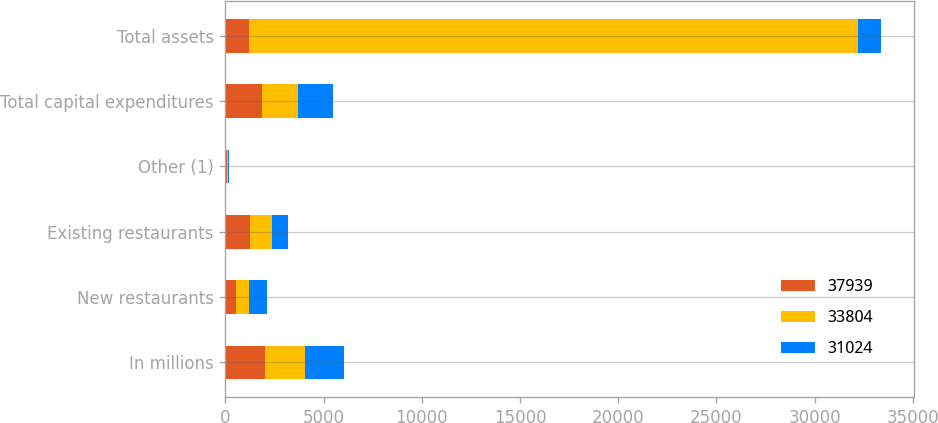<chart> <loc_0><loc_0><loc_500><loc_500><stacked_bar_chart><ecel><fcel>In millions<fcel>New restaurants<fcel>Existing restaurants<fcel>Other (1)<fcel>Total capital expenditures<fcel>Total assets<nl><fcel>37939<fcel>2017<fcel>537<fcel>1236<fcel>81<fcel>1854<fcel>1172<nl><fcel>33804<fcel>2016<fcel>674<fcel>1108<fcel>39<fcel>1821<fcel>31024<nl><fcel>31024<fcel>2015<fcel>892<fcel>842<fcel>80<fcel>1814<fcel>1172<nl></chart> 